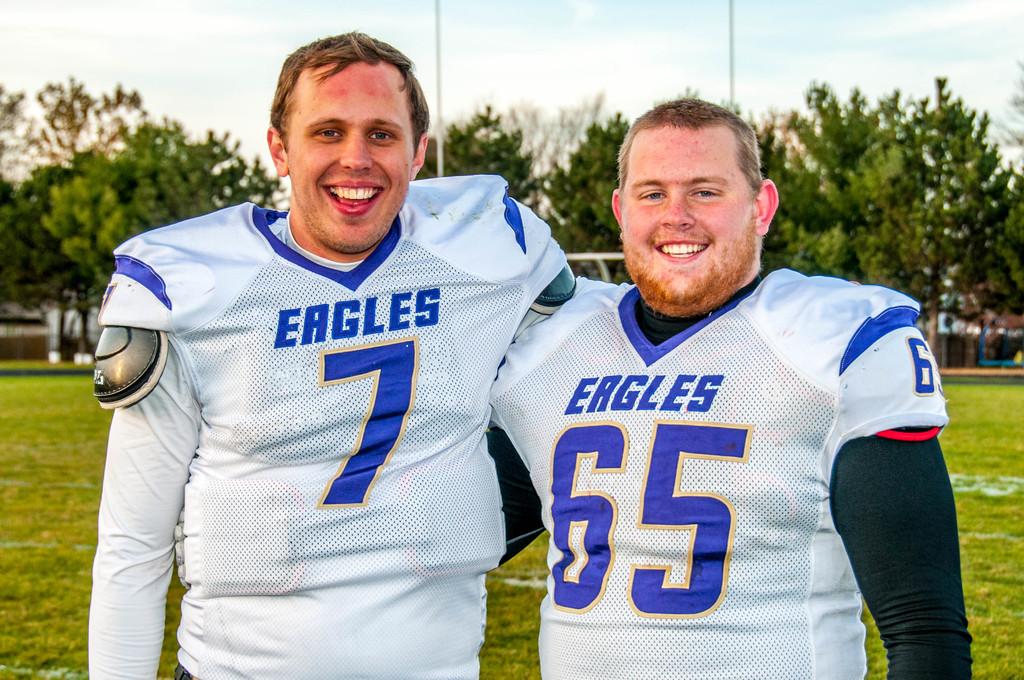What number is on the boy on the right's jersey?
Provide a short and direct response. 65. 